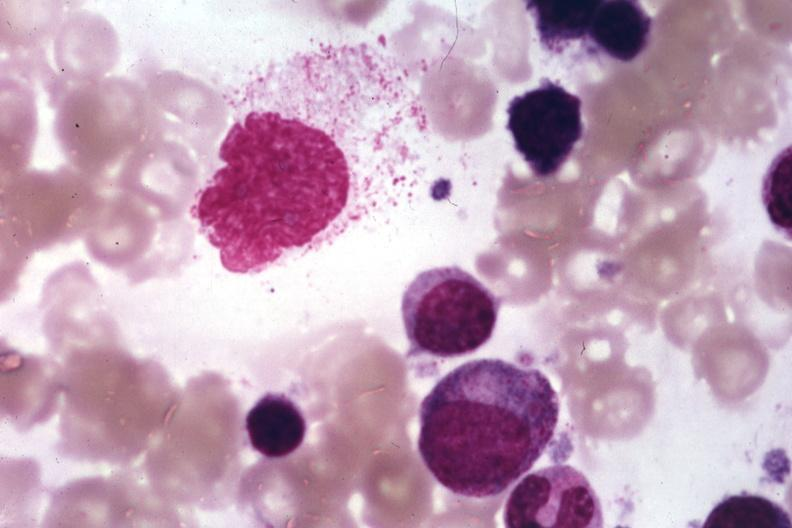s carcinoma metastatic lung present?
Answer the question using a single word or phrase. No 